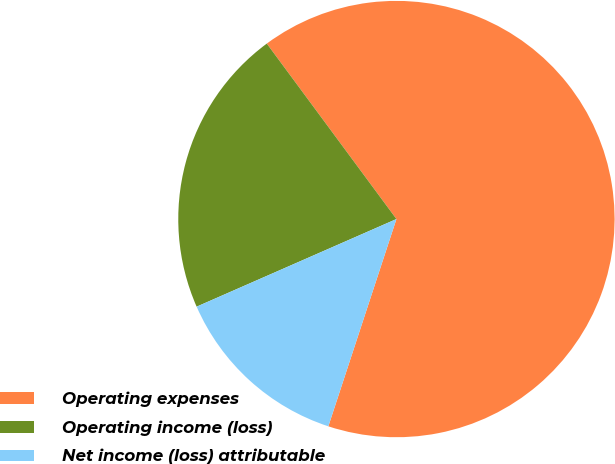<chart> <loc_0><loc_0><loc_500><loc_500><pie_chart><fcel>Operating expenses<fcel>Operating income (loss)<fcel>Net income (loss) attributable<nl><fcel>65.18%<fcel>21.45%<fcel>13.37%<nl></chart> 